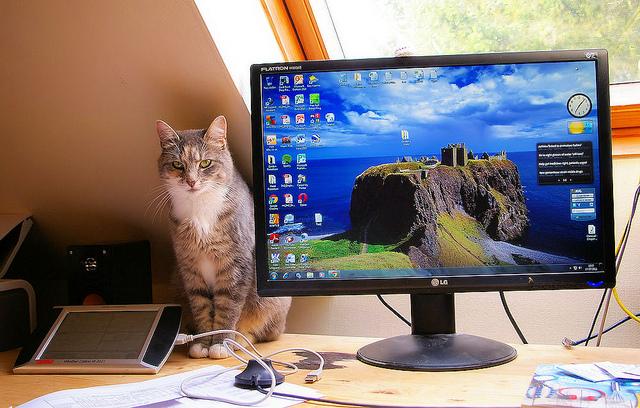Is the cat on Facebook?
Be succinct. No. Where is the cat?
Concise answer only. On desk. What is on the computer screen?
Give a very brief answer. Rock. 